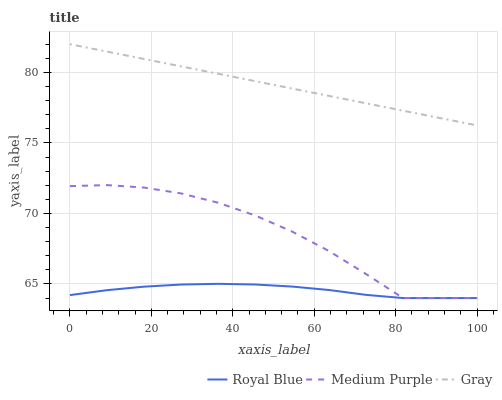Does Royal Blue have the minimum area under the curve?
Answer yes or no. Yes. Does Gray have the maximum area under the curve?
Answer yes or no. Yes. Does Gray have the minimum area under the curve?
Answer yes or no. No. Does Royal Blue have the maximum area under the curve?
Answer yes or no. No. Is Gray the smoothest?
Answer yes or no. Yes. Is Medium Purple the roughest?
Answer yes or no. Yes. Is Royal Blue the smoothest?
Answer yes or no. No. Is Royal Blue the roughest?
Answer yes or no. No. Does Gray have the lowest value?
Answer yes or no. No. Does Royal Blue have the highest value?
Answer yes or no. No. Is Medium Purple less than Gray?
Answer yes or no. Yes. Is Gray greater than Royal Blue?
Answer yes or no. Yes. Does Medium Purple intersect Gray?
Answer yes or no. No. 